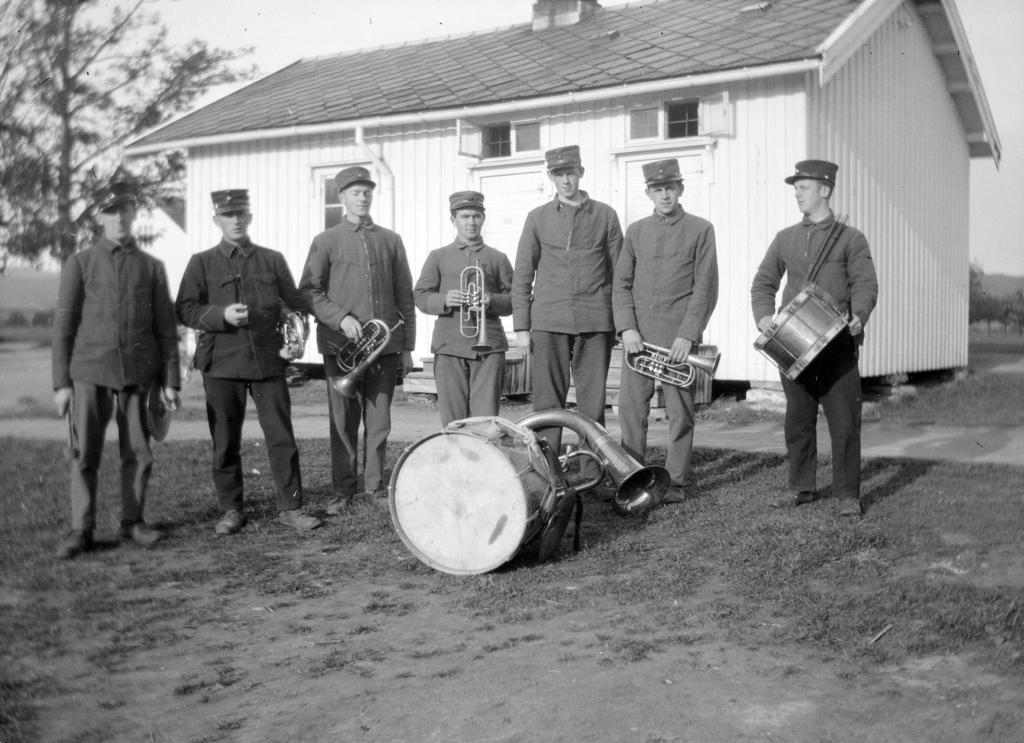Please provide a concise description of this image. In the center we can see few persons were standing. And they were holding the instruments. The front we can see the drum. Coming to the background we can see the house and tree. 